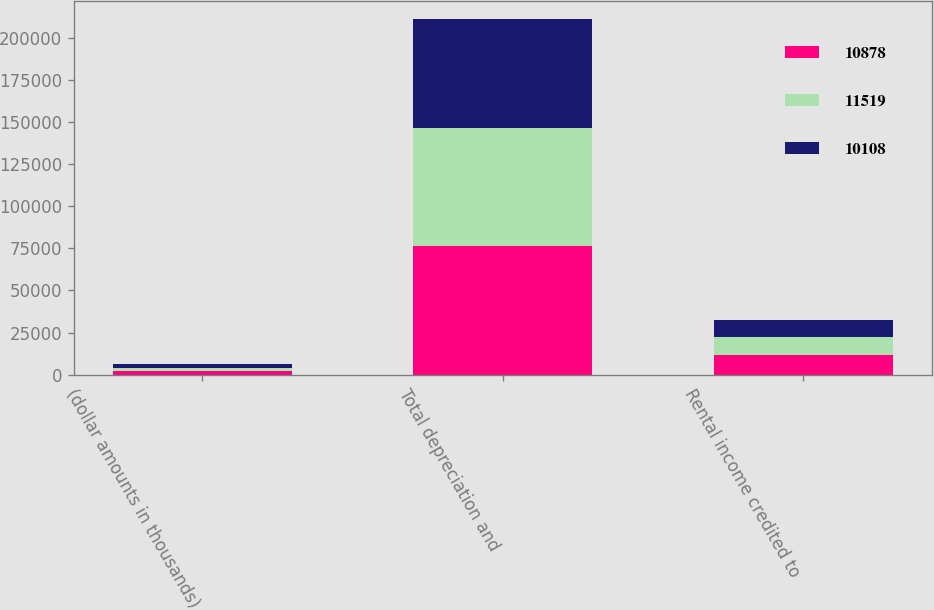Convert chart. <chart><loc_0><loc_0><loc_500><loc_500><stacked_bar_chart><ecel><fcel>(dollar amounts in thousands)<fcel>Total depreciation and<fcel>Rental income credited to<nl><fcel>10878<fcel>2012<fcel>76170<fcel>11519<nl><fcel>11519<fcel>2011<fcel>70413<fcel>10878<nl><fcel>10108<fcel>2010<fcel>64934<fcel>10108<nl></chart> 